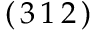<formula> <loc_0><loc_0><loc_500><loc_500>( \, 3 \, 1 \, 2 \, )</formula> 